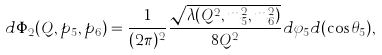<formula> <loc_0><loc_0><loc_500><loc_500>d \Phi _ { 2 } ( Q , p _ { 5 } , p _ { 6 } ) = \frac { 1 } { ( 2 \pi ) ^ { 2 } } \frac { \sqrt { \lambda ( Q ^ { 2 } , m _ { 5 } ^ { 2 } , m _ { 6 } ^ { 2 } ) } } { 8 Q ^ { 2 } } d \varphi _ { 5 } d ( \cos \theta _ { 5 } ) ,</formula> 